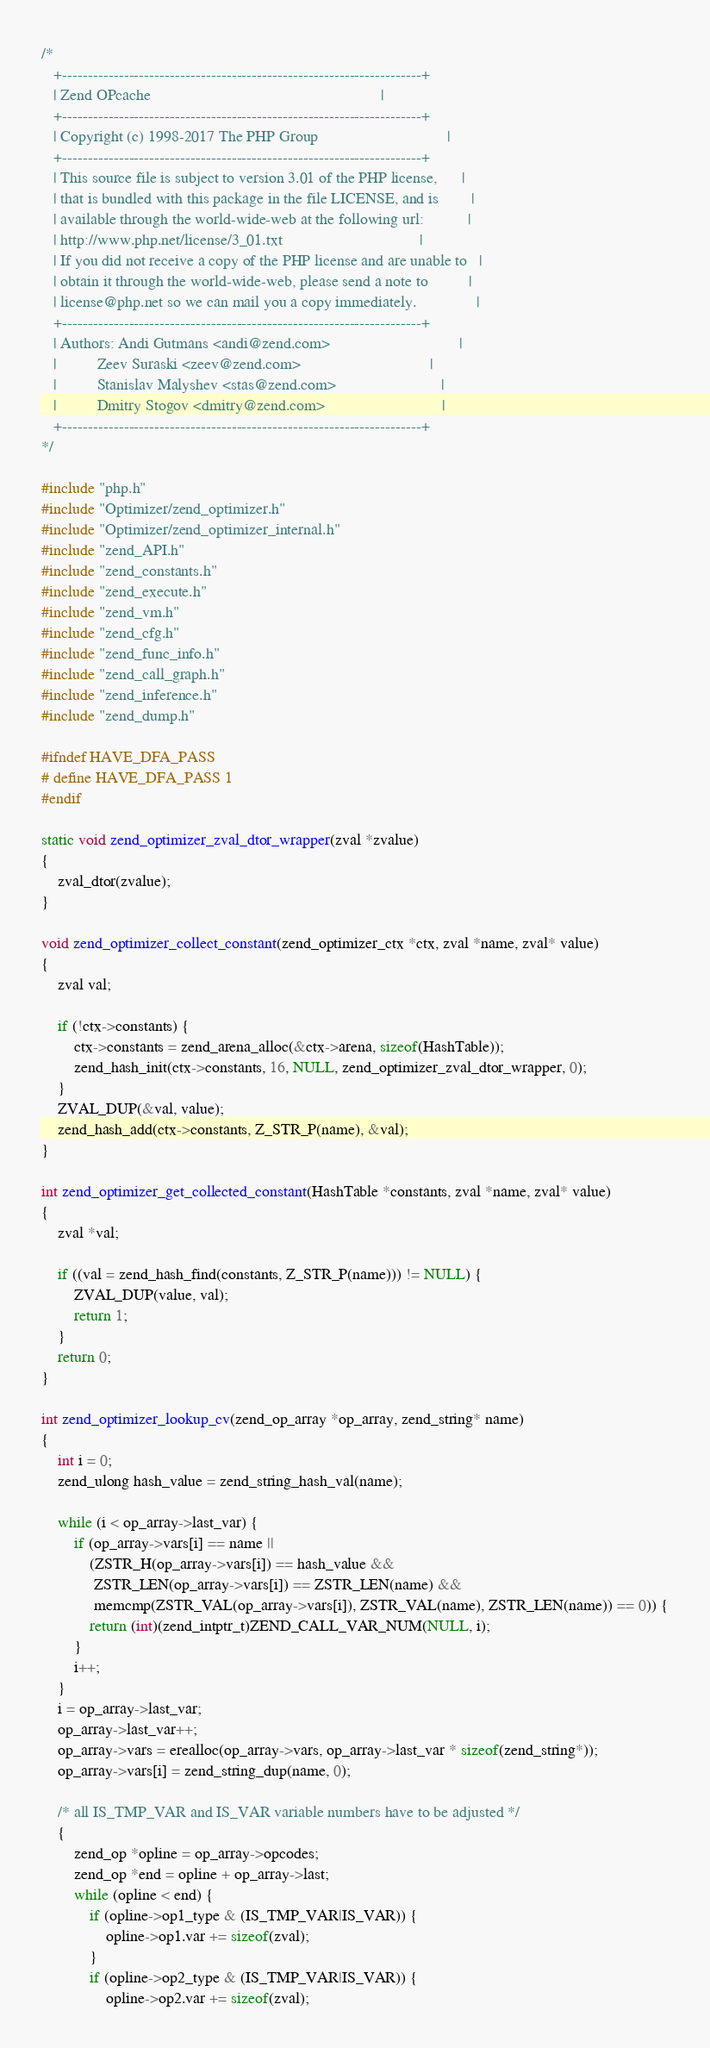<code> <loc_0><loc_0><loc_500><loc_500><_C_>/*
   +----------------------------------------------------------------------+
   | Zend OPcache                                                         |
   +----------------------------------------------------------------------+
   | Copyright (c) 1998-2017 The PHP Group                                |
   +----------------------------------------------------------------------+
   | This source file is subject to version 3.01 of the PHP license,      |
   | that is bundled with this package in the file LICENSE, and is        |
   | available through the world-wide-web at the following url:           |
   | http://www.php.net/license/3_01.txt                                  |
   | If you did not receive a copy of the PHP license and are unable to   |
   | obtain it through the world-wide-web, please send a note to          |
   | license@php.net so we can mail you a copy immediately.               |
   +----------------------------------------------------------------------+
   | Authors: Andi Gutmans <andi@zend.com>                                |
   |          Zeev Suraski <zeev@zend.com>                                |
   |          Stanislav Malyshev <stas@zend.com>                          |
   |          Dmitry Stogov <dmitry@zend.com>                             |
   +----------------------------------------------------------------------+
*/

#include "php.h"
#include "Optimizer/zend_optimizer.h"
#include "Optimizer/zend_optimizer_internal.h"
#include "zend_API.h"
#include "zend_constants.h"
#include "zend_execute.h"
#include "zend_vm.h"
#include "zend_cfg.h"
#include "zend_func_info.h"
#include "zend_call_graph.h"
#include "zend_inference.h"
#include "zend_dump.h"

#ifndef HAVE_DFA_PASS
# define HAVE_DFA_PASS 1
#endif

static void zend_optimizer_zval_dtor_wrapper(zval *zvalue)
{
	zval_dtor(zvalue);
}

void zend_optimizer_collect_constant(zend_optimizer_ctx *ctx, zval *name, zval* value)
{
	zval val;

	if (!ctx->constants) {
		ctx->constants = zend_arena_alloc(&ctx->arena, sizeof(HashTable));
		zend_hash_init(ctx->constants, 16, NULL, zend_optimizer_zval_dtor_wrapper, 0);
	}
	ZVAL_DUP(&val, value);
	zend_hash_add(ctx->constants, Z_STR_P(name), &val);
}

int zend_optimizer_get_collected_constant(HashTable *constants, zval *name, zval* value)
{
	zval *val;

	if ((val = zend_hash_find(constants, Z_STR_P(name))) != NULL) {
		ZVAL_DUP(value, val);
		return 1;
	}
	return 0;
}

int zend_optimizer_lookup_cv(zend_op_array *op_array, zend_string* name)
{
	int i = 0;
	zend_ulong hash_value = zend_string_hash_val(name);

	while (i < op_array->last_var) {
		if (op_array->vars[i] == name ||
		    (ZSTR_H(op_array->vars[i]) == hash_value &&
		     ZSTR_LEN(op_array->vars[i]) == ZSTR_LEN(name) &&
		     memcmp(ZSTR_VAL(op_array->vars[i]), ZSTR_VAL(name), ZSTR_LEN(name)) == 0)) {
			return (int)(zend_intptr_t)ZEND_CALL_VAR_NUM(NULL, i);
		}
		i++;
	}
	i = op_array->last_var;
	op_array->last_var++;
	op_array->vars = erealloc(op_array->vars, op_array->last_var * sizeof(zend_string*));
	op_array->vars[i] = zend_string_dup(name, 0);

	/* all IS_TMP_VAR and IS_VAR variable numbers have to be adjusted */
	{
		zend_op *opline = op_array->opcodes;
		zend_op *end = opline + op_array->last;
		while (opline < end) {
			if (opline->op1_type & (IS_TMP_VAR|IS_VAR)) {
				opline->op1.var += sizeof(zval);
			}
			if (opline->op2_type & (IS_TMP_VAR|IS_VAR)) {
				opline->op2.var += sizeof(zval);</code> 